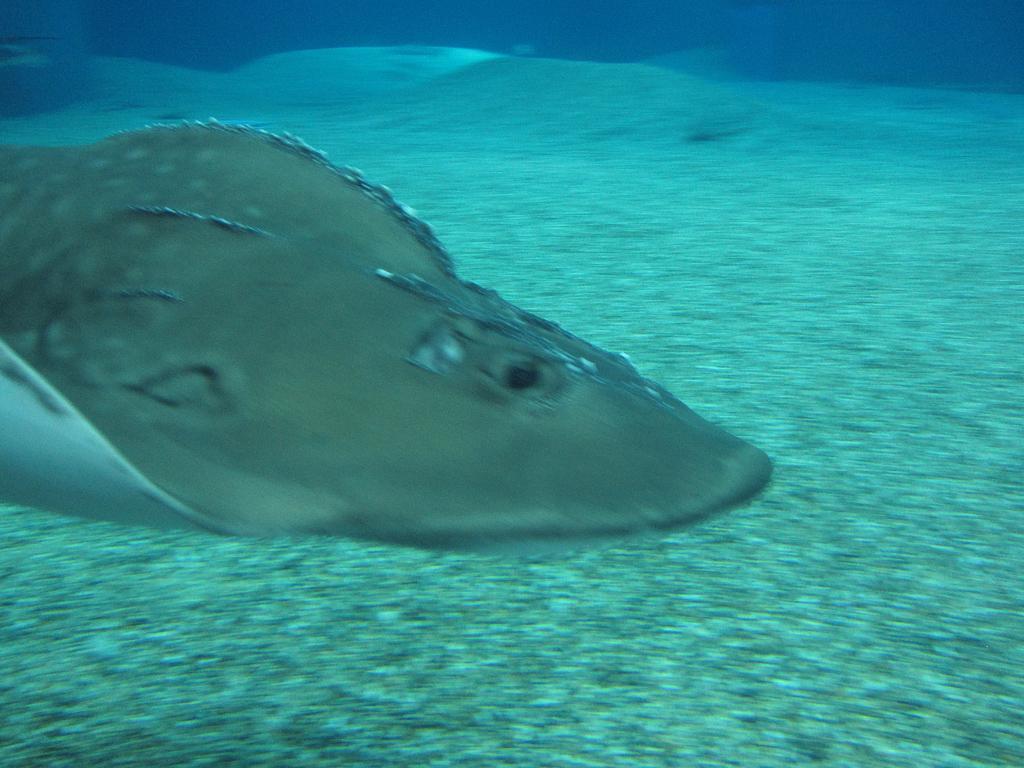Describe this image in one or two sentences. In this image we can see a animal in the sea. 